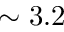<formula> <loc_0><loc_0><loc_500><loc_500>\sim 3 . 2</formula> 